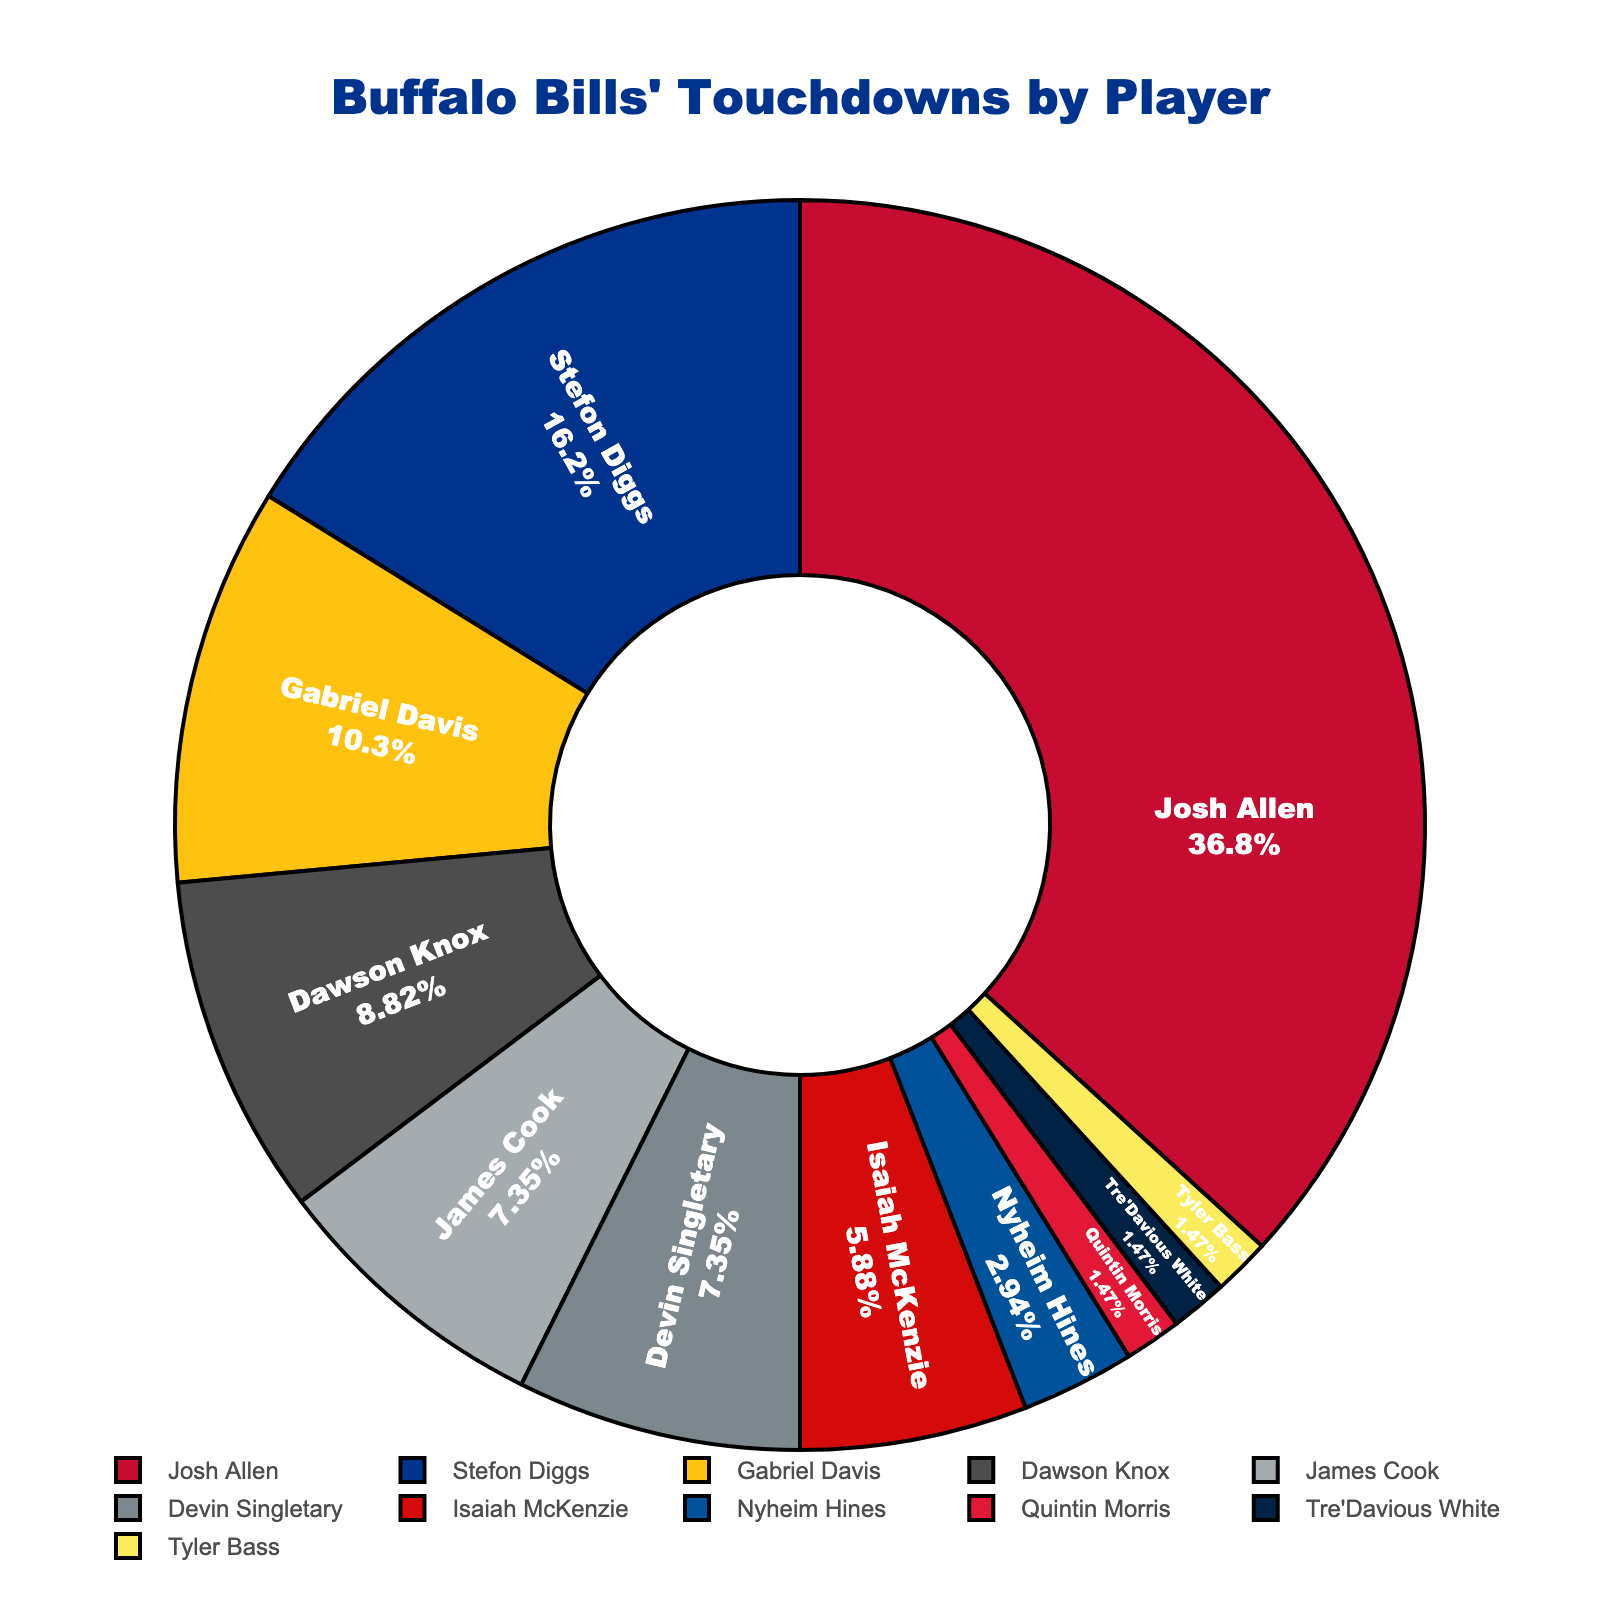Which player scored the most touchdowns? The player with the largest segment in the pie chart represents the player with the most touchdowns. By examining the chart, Josh Allen's segment is the largest.
Answer: Josh Allen How many more touchdowns did Stefon Diggs score compared to Gabriel Davis? Stefon Diggs scored 11 touchdowns and Gabriel Davis scored 7 touchdowns. The difference is calculated as 11 - 7.
Answer: 4 What's the total number of touchdowns scored by players other than Josh Allen? To find this, sum all touchdowns except Josh Allen's: 11 (Stefon Diggs) + 7 (Gabriel Davis) + 6 (Dawson Knox) + 5 (James Cook) + 5 (Devin Singletary) + 4 (Isaiah McKenzie) + 2 (Nyheim Hines) + 1 (Quintin Morris) + 1 (Tre'Davious White) + 1 (Tyler Bass) = 43
Answer: 43 Are there more touchdowns by wide receivers (Stefon Diggs, Gabriel Davis, Isaiah McKenzie) or running backs (Devin Singletary, James Cook, Nyheim Hines)? Sum touchdowns for each group: Wide receivers have 11 (Stefon Diggs) + 7 (Gabriel Davis) + 4 (Isaiah McKenzie) = 22; Running backs have 5 (James Cook) + 5 (Devin Singletary) + 2 (Nyheim Hines) = 12. Comparing 22 and 12, wide receivers scored more.
Answer: Wide receivers Which player has a segment with a different color from most other players? Tre'Davious White, with only 1 touchdown, has a distinctly colored small segment to visually differentiate from players with more touchdowns.
Answer: Tre'Davious White 